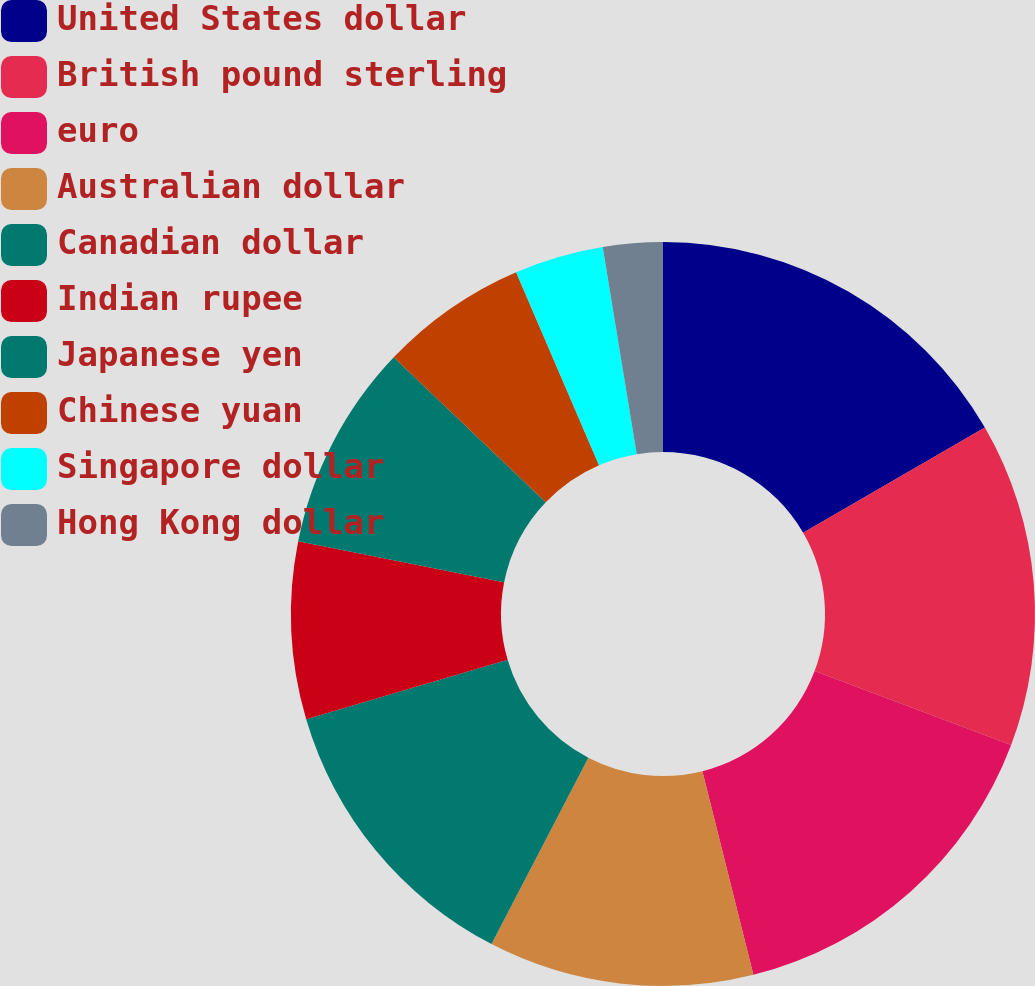Convert chart. <chart><loc_0><loc_0><loc_500><loc_500><pie_chart><fcel>United States dollar<fcel>British pound sterling<fcel>euro<fcel>Australian dollar<fcel>Canadian dollar<fcel>Indian rupee<fcel>Japanese yen<fcel>Chinese yuan<fcel>Singapore dollar<fcel>Hong Kong dollar<nl><fcel>16.64%<fcel>14.09%<fcel>15.36%<fcel>11.53%<fcel>12.81%<fcel>7.7%<fcel>8.98%<fcel>6.42%<fcel>3.87%<fcel>2.59%<nl></chart> 